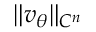<formula> <loc_0><loc_0><loc_500><loc_500>\| v _ { \theta } \| _ { C ^ { n } }</formula> 